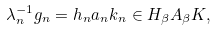Convert formula to latex. <formula><loc_0><loc_0><loc_500><loc_500>\lambda ^ { - 1 } _ { n } g _ { n } = h _ { n } a _ { n } k _ { n } \in H _ { \beta } A _ { \beta } K ,</formula> 